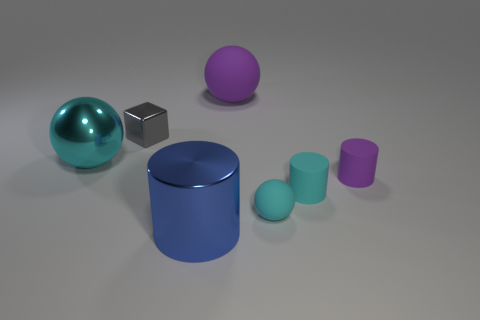Subtract all green cylinders. How many cyan balls are left? 2 Subtract all metal balls. How many balls are left? 2 Add 3 large yellow cubes. How many objects exist? 10 Subtract all balls. How many objects are left? 4 Add 1 metallic blocks. How many metallic blocks are left? 2 Add 6 large brown matte cubes. How many large brown matte cubes exist? 6 Subtract 0 cyan blocks. How many objects are left? 7 Subtract all metal cylinders. Subtract all tiny cyan balls. How many objects are left? 5 